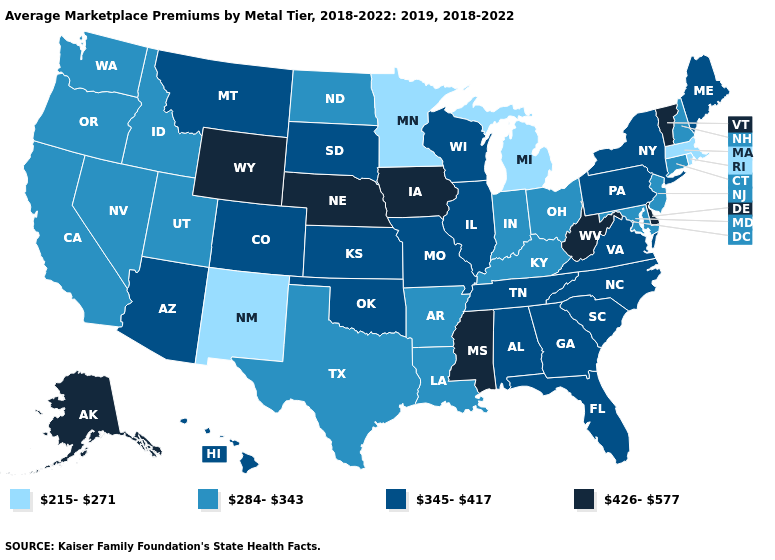What is the value of South Carolina?
Give a very brief answer. 345-417. Does the first symbol in the legend represent the smallest category?
Short answer required. Yes. Which states have the lowest value in the USA?
Short answer required. Massachusetts, Michigan, Minnesota, New Mexico, Rhode Island. What is the value of Connecticut?
Short answer required. 284-343. Name the states that have a value in the range 215-271?
Keep it brief. Massachusetts, Michigan, Minnesota, New Mexico, Rhode Island. Name the states that have a value in the range 426-577?
Concise answer only. Alaska, Delaware, Iowa, Mississippi, Nebraska, Vermont, West Virginia, Wyoming. Does Pennsylvania have a higher value than Virginia?
Give a very brief answer. No. Does Iowa have the highest value in the USA?
Write a very short answer. Yes. Which states hav the highest value in the West?
Write a very short answer. Alaska, Wyoming. What is the highest value in the USA?
Short answer required. 426-577. Which states have the lowest value in the USA?
Give a very brief answer. Massachusetts, Michigan, Minnesota, New Mexico, Rhode Island. Does the map have missing data?
Short answer required. No. What is the value of Mississippi?
Concise answer only. 426-577. What is the highest value in the USA?
Be succinct. 426-577. What is the highest value in states that border Ohio?
Quick response, please. 426-577. 